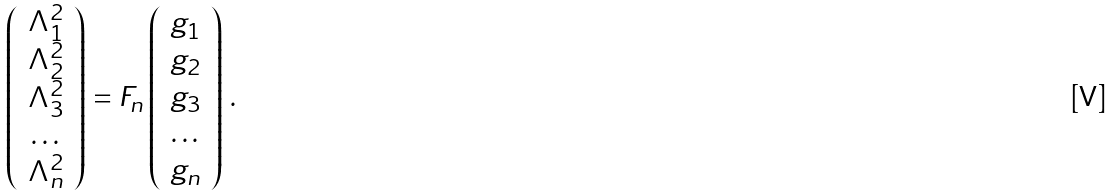<formula> <loc_0><loc_0><loc_500><loc_500>\left ( \begin{array} { c } \Lambda _ { 1 } ^ { 2 } \\ \Lambda _ { 2 } ^ { 2 } \\ \Lambda _ { 3 } ^ { 2 } \\ \dots \\ \Lambda _ { n } ^ { 2 } \end{array} \right ) & = F _ { n } \left ( \begin{array} { c } g _ { 1 } \\ g _ { 2 } \\ g _ { 3 } \\ \dots \\ g _ { n } \end{array} \right ) \, .</formula> 